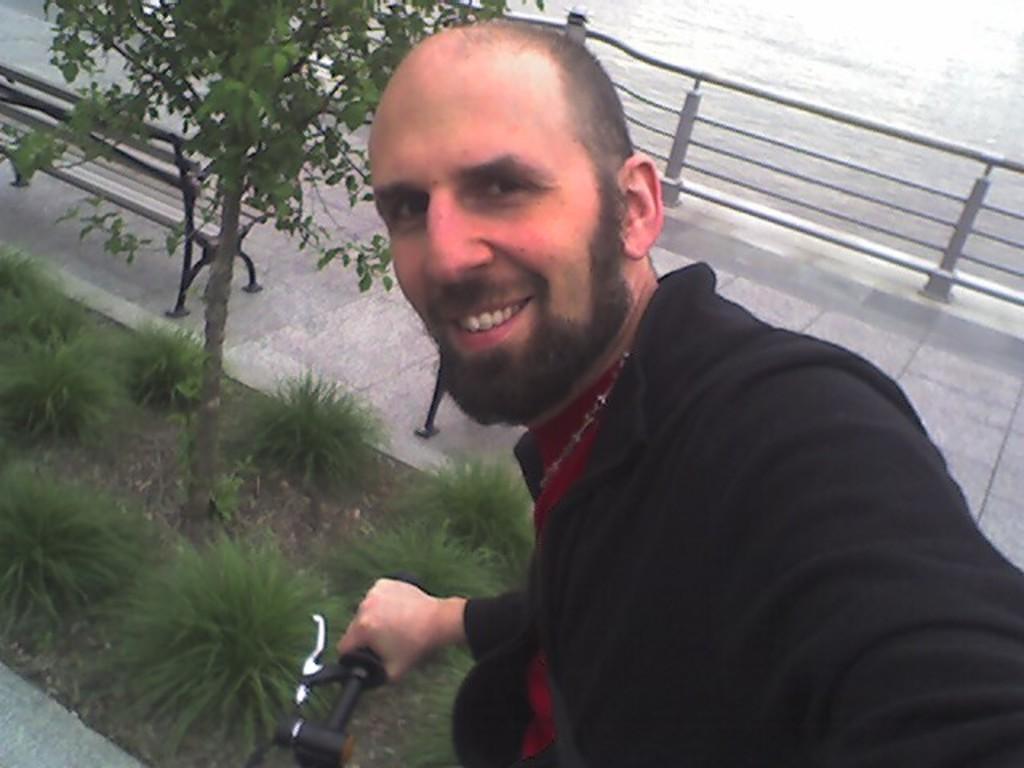Describe this image in one or two sentences. As we can see in the image, there is a road, fence, plant, bench, grass and a man holding bicycle. 